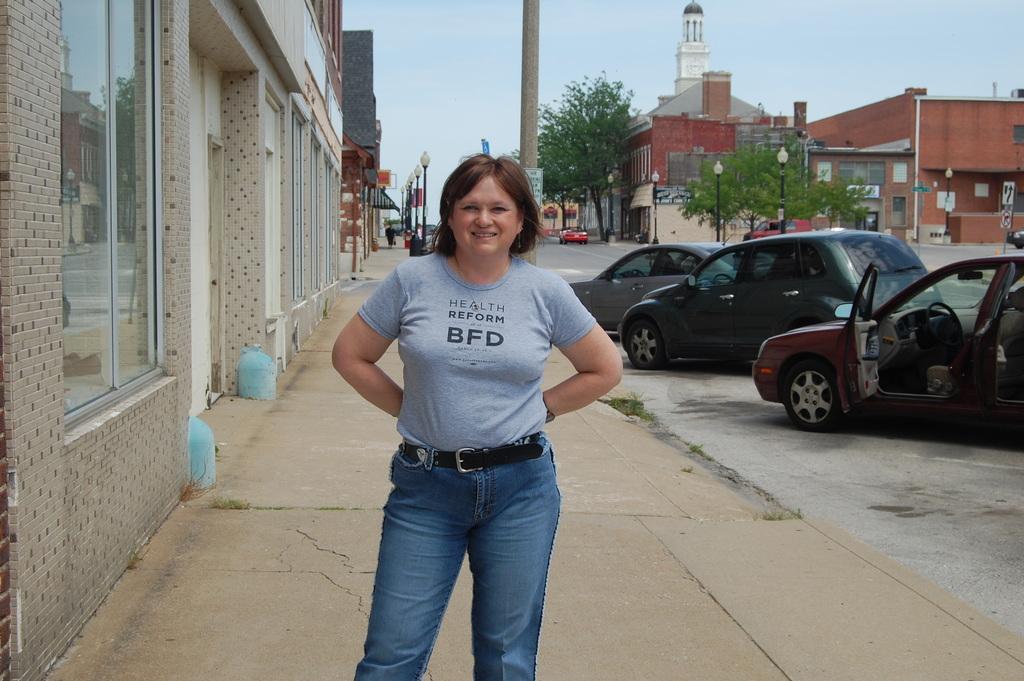Describe this image in one or two sentences. In the center of the image we can see a woman is standing and she is smiling. On the right side of the image, we can see a few vehicles on the road. In the background, we can see the sky, buildings, poles, trees and some objects. 